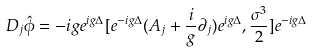<formula> <loc_0><loc_0><loc_500><loc_500>D _ { j } \hat { \phi } = - i g e ^ { i g \Delta } [ e ^ { - i g \Delta } ( A _ { j } + \frac { i } { g } \partial _ { j } ) e ^ { i g \Delta } , \frac { \sigma ^ { 3 } } { 2 } ] e ^ { - i g \Delta }</formula> 